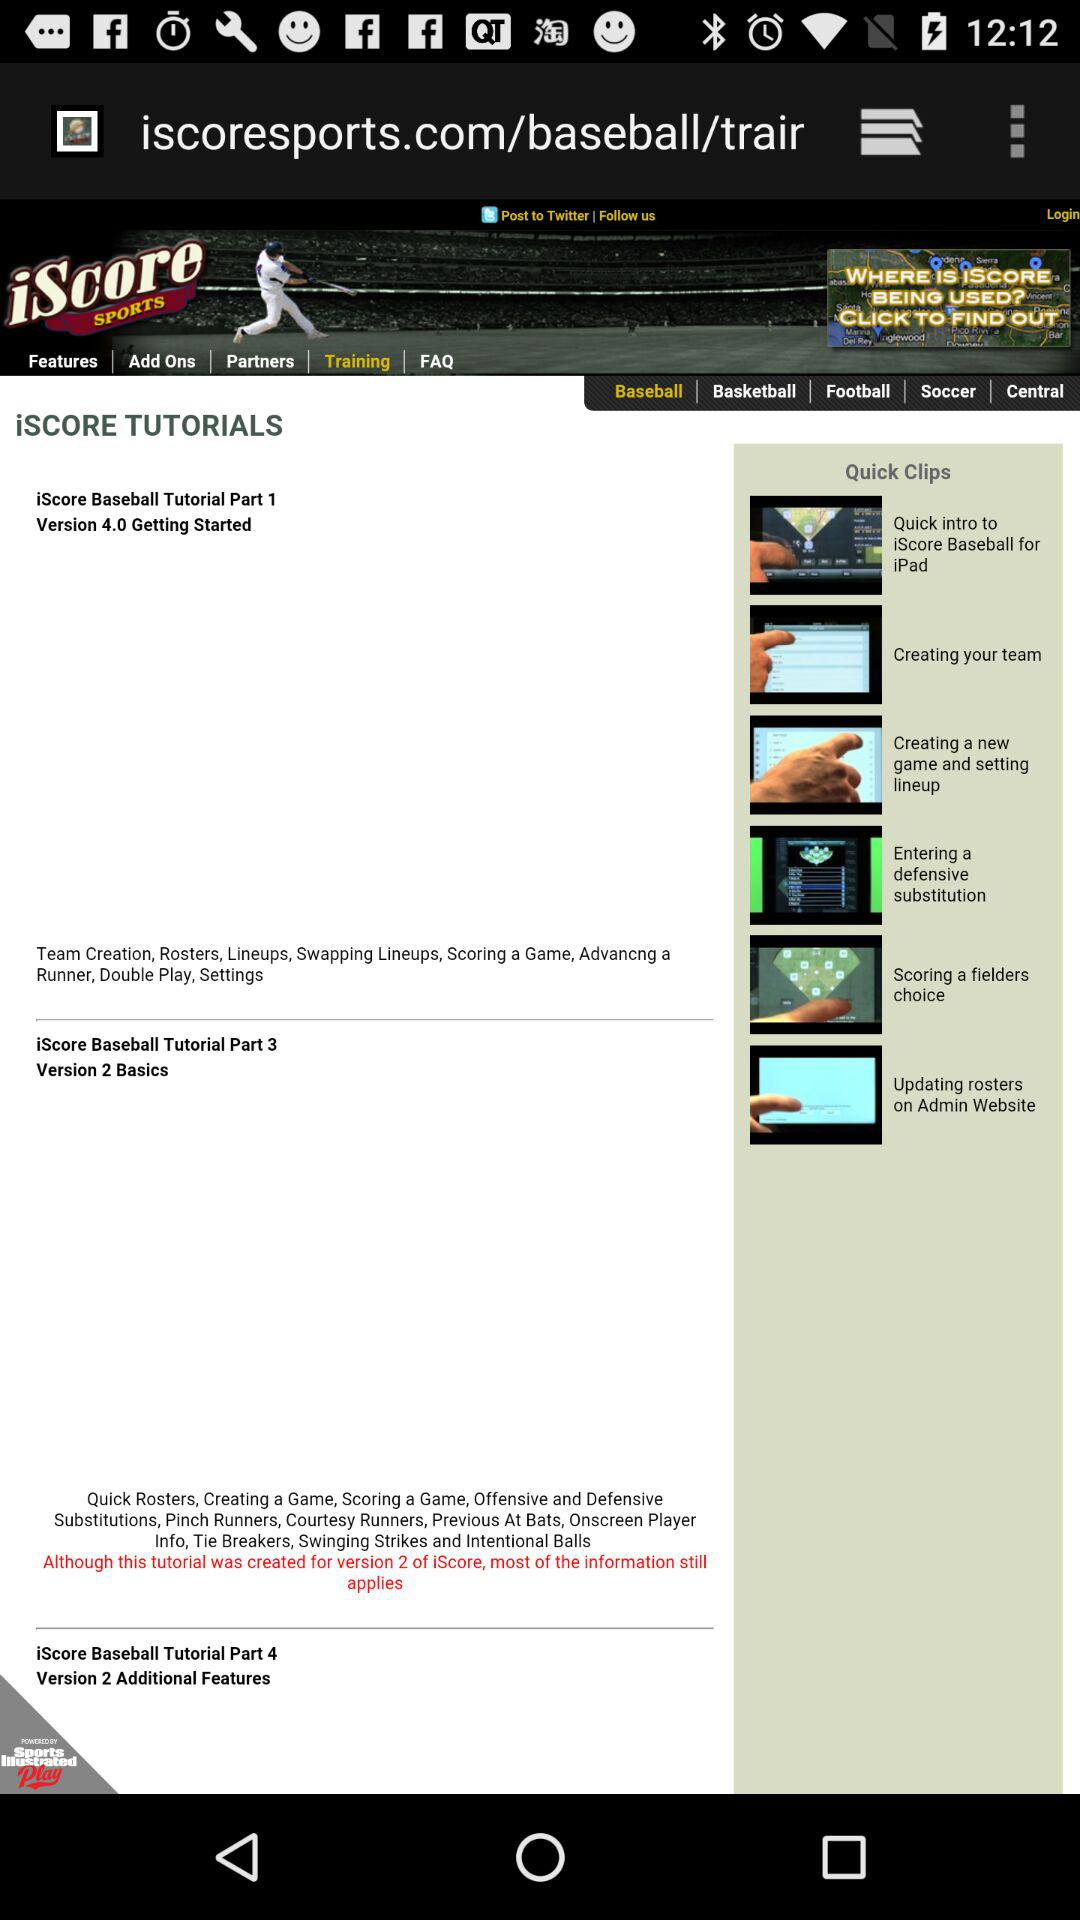What's the part number of "Baseball Tutorial Version 4.0"? The part number for "Baseball Tutorial Version 4.0" is 1. 